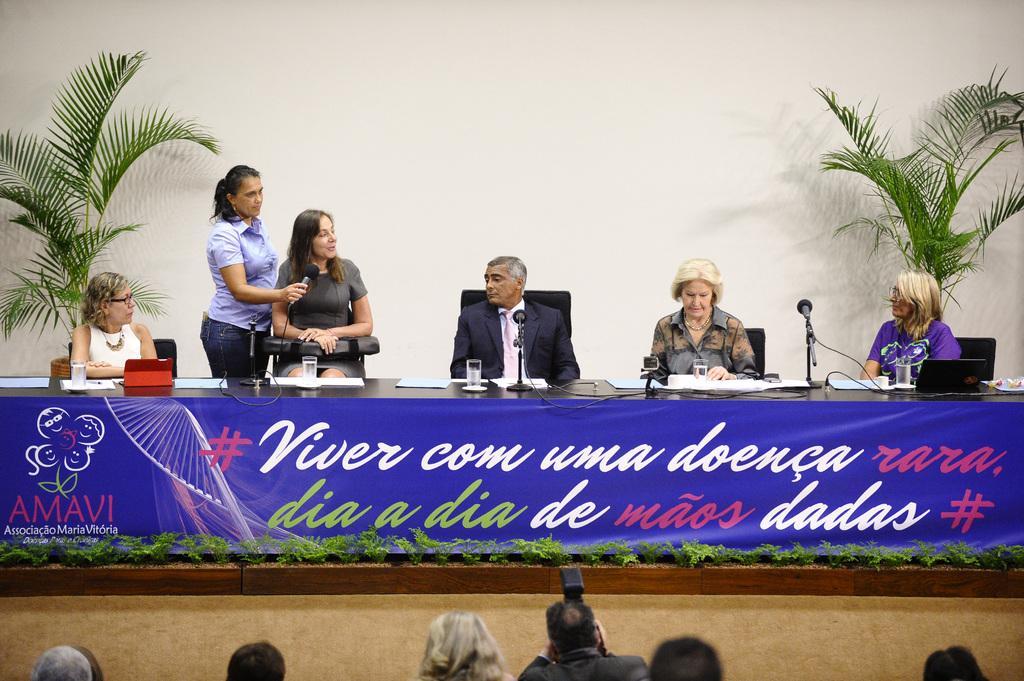Describe this image in one or two sentences. In this image we can see chairs, people, mikes, glasses, laptop, plants and we can also see a banner with some text. 